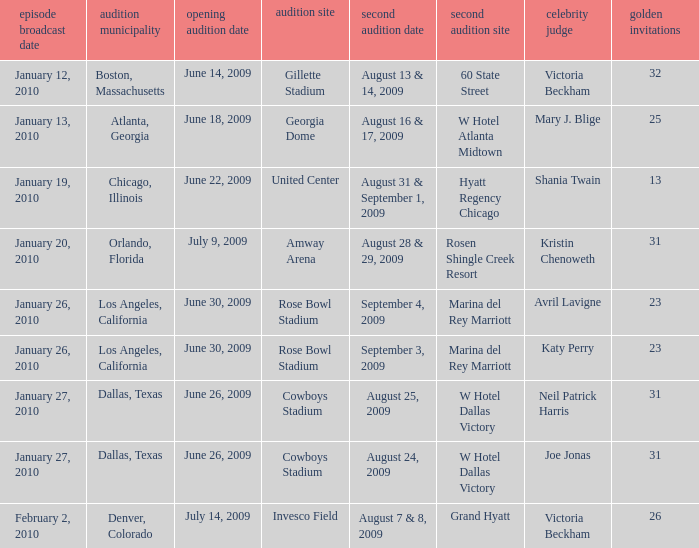Name the callback date for amway arena August 28 & 29, 2009. 